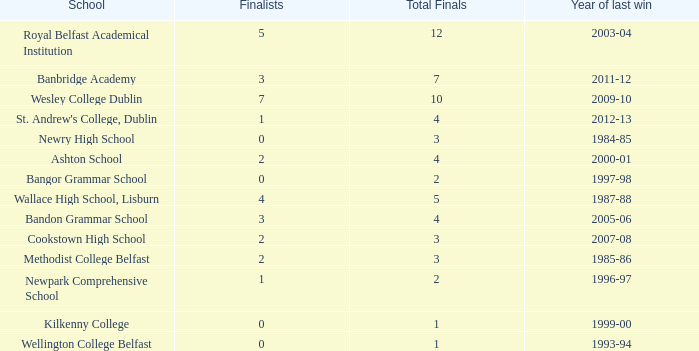Would you mind parsing the complete table? {'header': ['School', 'Finalists', 'Total Finals', 'Year of last win'], 'rows': [['Royal Belfast Academical Institution', '5', '12', '2003-04'], ['Banbridge Academy', '3', '7', '2011-12'], ['Wesley College Dublin', '7', '10', '2009-10'], ["St. Andrew's College, Dublin", '1', '4', '2012-13'], ['Newry High School', '0', '3', '1984-85'], ['Ashton School', '2', '4', '2000-01'], ['Bangor Grammar School', '0', '2', '1997-98'], ['Wallace High School, Lisburn', '4', '5', '1987-88'], ['Bandon Grammar School', '3', '4', '2005-06'], ['Cookstown High School', '2', '3', '2007-08'], ['Methodist College Belfast', '2', '3', '1985-86'], ['Newpark Comprehensive School', '1', '2', '1996-97'], ['Kilkenny College', '0', '1', '1999-00'], ['Wellington College Belfast', '0', '1', '1993-94']]} What are the names that had a finalist score of 2? Ashton School, Cookstown High School, Methodist College Belfast. 